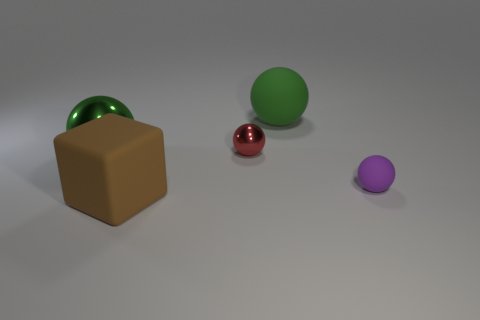Subtract all large green matte balls. How many balls are left? 3 Subtract all red balls. How many balls are left? 3 Add 2 big green things. How many objects exist? 7 Subtract all balls. How many objects are left? 1 Add 1 tiny yellow matte things. How many tiny yellow matte things exist? 1 Subtract 0 brown cylinders. How many objects are left? 5 Subtract 1 blocks. How many blocks are left? 0 Subtract all red spheres. Subtract all blue cylinders. How many spheres are left? 3 Subtract all yellow cylinders. How many purple balls are left? 1 Subtract all large purple matte balls. Subtract all small metallic objects. How many objects are left? 4 